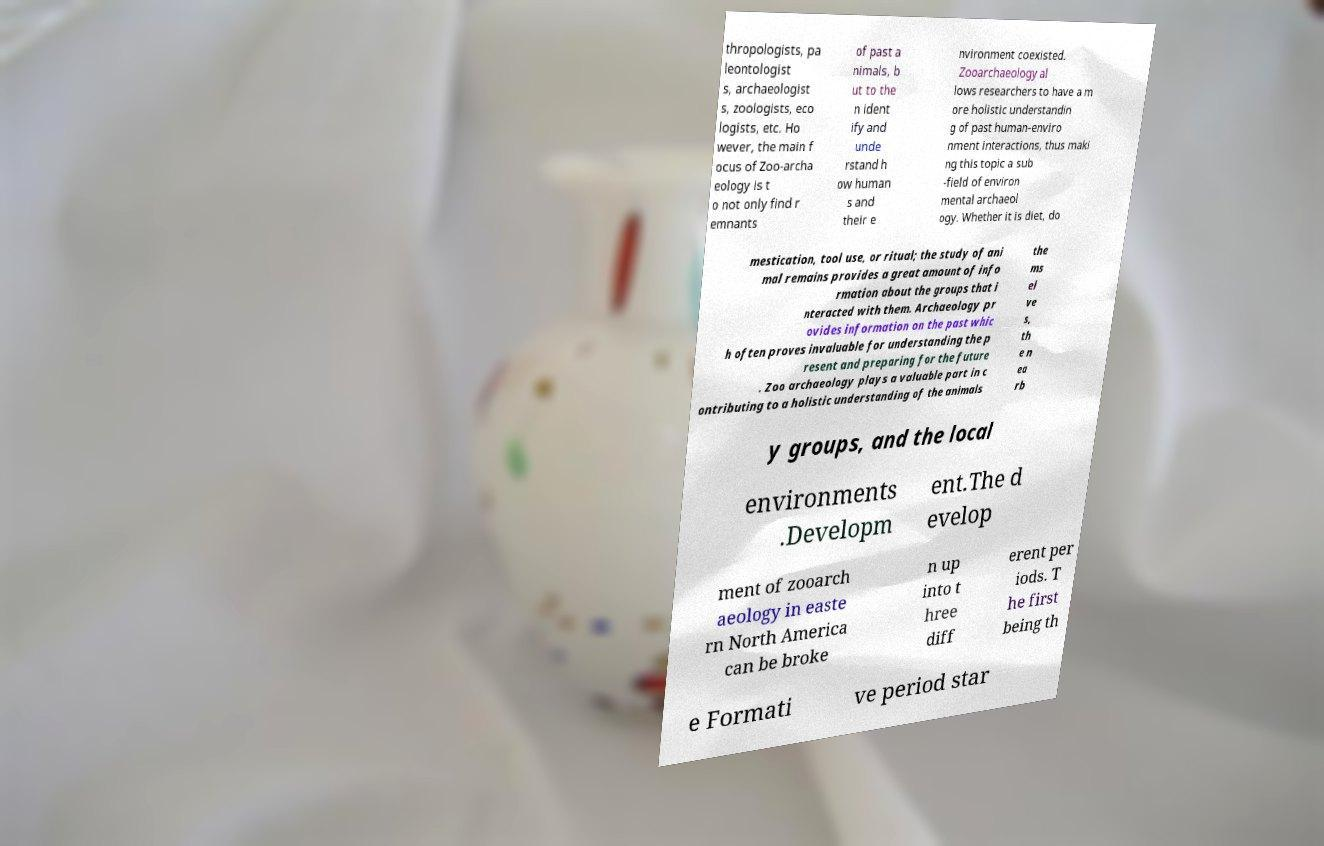For documentation purposes, I need the text within this image transcribed. Could you provide that? thropologists, pa leontologist s, archaeologist s, zoologists, eco logists, etc. Ho wever, the main f ocus of Zoo-archa eology is t o not only find r emnants of past a nimals, b ut to the n ident ify and unde rstand h ow human s and their e nvironment coexisted. Zooarchaeology al lows researchers to have a m ore holistic understandin g of past human-enviro nment interactions, thus maki ng this topic a sub -field of environ mental archaeol ogy. Whether it is diet, do mestication, tool use, or ritual; the study of ani mal remains provides a great amount of info rmation about the groups that i nteracted with them. Archaeology pr ovides information on the past whic h often proves invaluable for understanding the p resent and preparing for the future . Zoo archaeology plays a valuable part in c ontributing to a holistic understanding of the animals the ms el ve s, th e n ea rb y groups, and the local environments .Developm ent.The d evelop ment of zooarch aeology in easte rn North America can be broke n up into t hree diff erent per iods. T he first being th e Formati ve period star 